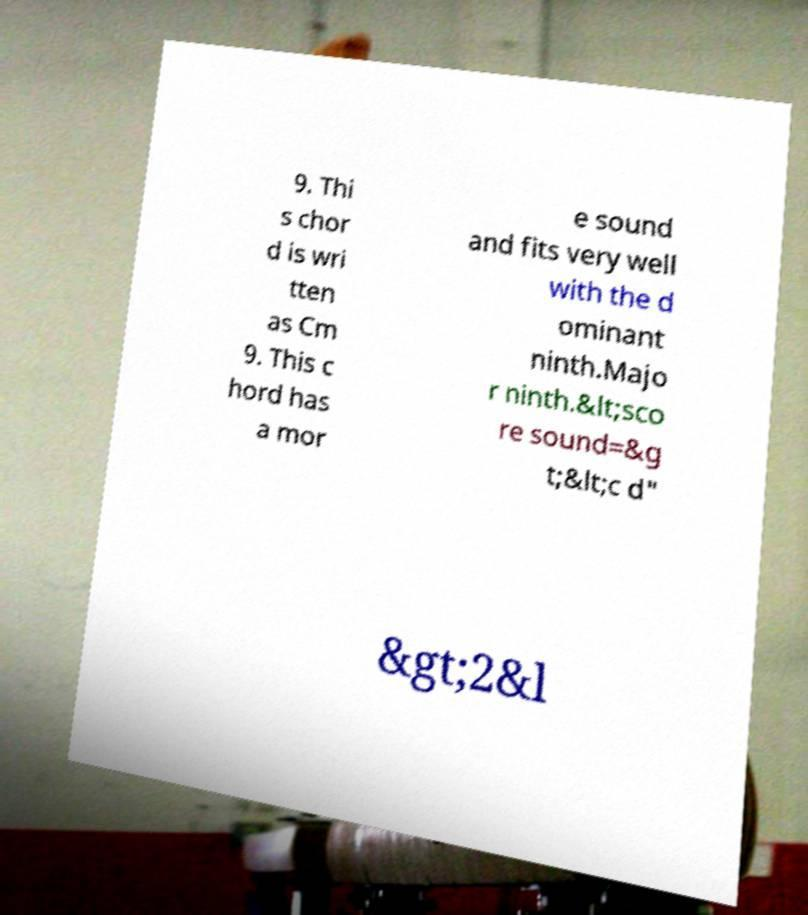Can you read and provide the text displayed in the image?This photo seems to have some interesting text. Can you extract and type it out for me? 9. Thi s chor d is wri tten as Cm 9. This c hord has a mor e sound and fits very well with the d ominant ninth.Majo r ninth.&lt;sco re sound=&g t;&lt;c d" &gt;2&l 